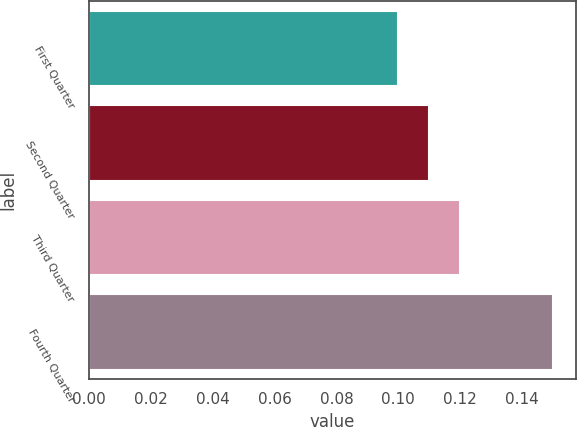Convert chart to OTSL. <chart><loc_0><loc_0><loc_500><loc_500><bar_chart><fcel>First Quarter<fcel>Second Quarter<fcel>Third Quarter<fcel>Fourth Quarter<nl><fcel>0.1<fcel>0.11<fcel>0.12<fcel>0.15<nl></chart> 